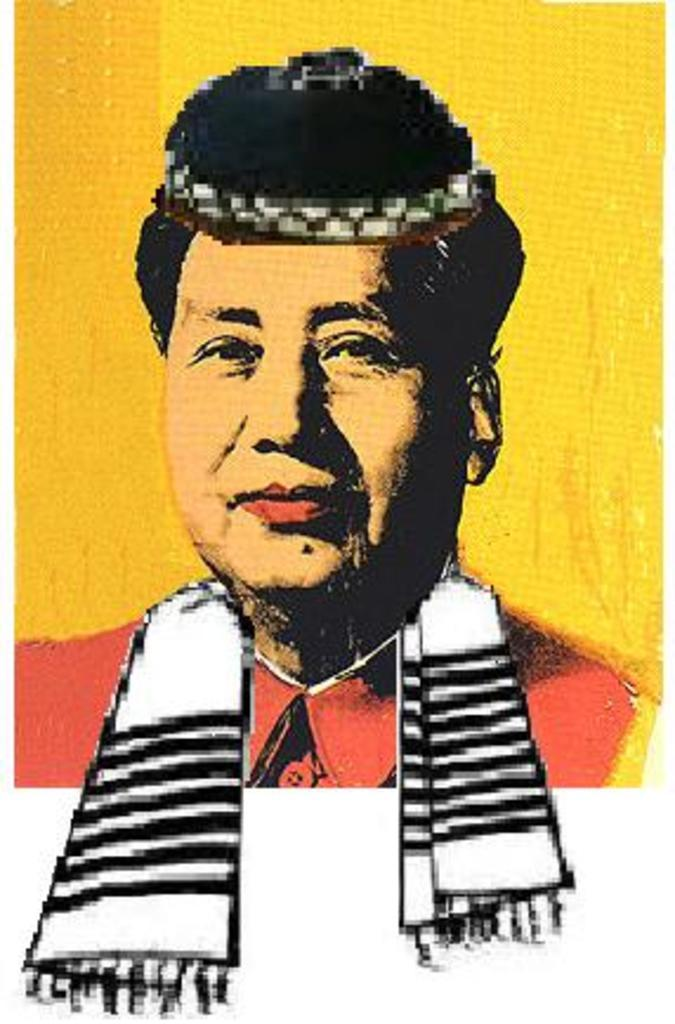What is present in the image that features a visual representation? There is a poster in the image. What can be seen on the poster? The poster has an image of a man. What color is the background of the image? The background of the image is yellow in color. What type of vessel is being used by the man in the image? There is no vessel present in the image, as it only features a poster with an image of a man. 